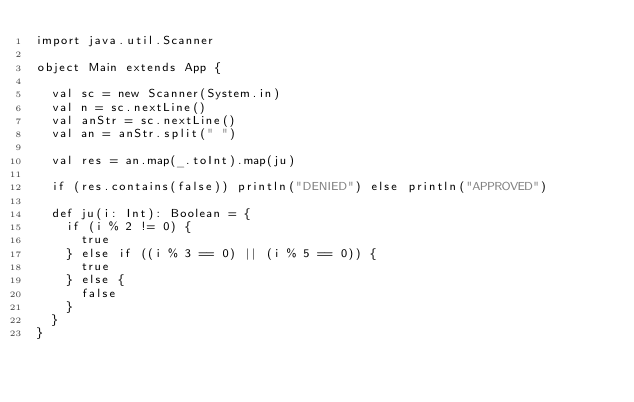Convert code to text. <code><loc_0><loc_0><loc_500><loc_500><_Scala_>import java.util.Scanner

object Main extends App {

  val sc = new Scanner(System.in)
  val n = sc.nextLine()
  val anStr = sc.nextLine()
  val an = anStr.split(" ")

  val res = an.map(_.toInt).map(ju)

  if (res.contains(false)) println("DENIED") else println("APPROVED")

  def ju(i: Int): Boolean = {
    if (i % 2 != 0) {
      true
    } else if ((i % 3 == 0) || (i % 5 == 0)) {
      true
    } else {
      false
    }
  }
}

</code> 